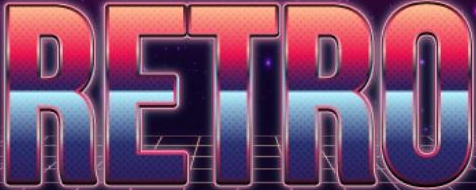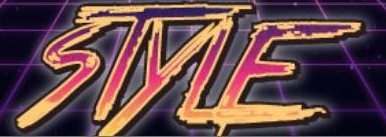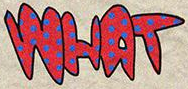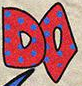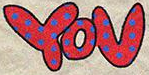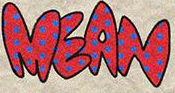What text appears in these images from left to right, separated by a semicolon? RETRO; STYLE; WHAT; DO; YOU; MEAN 